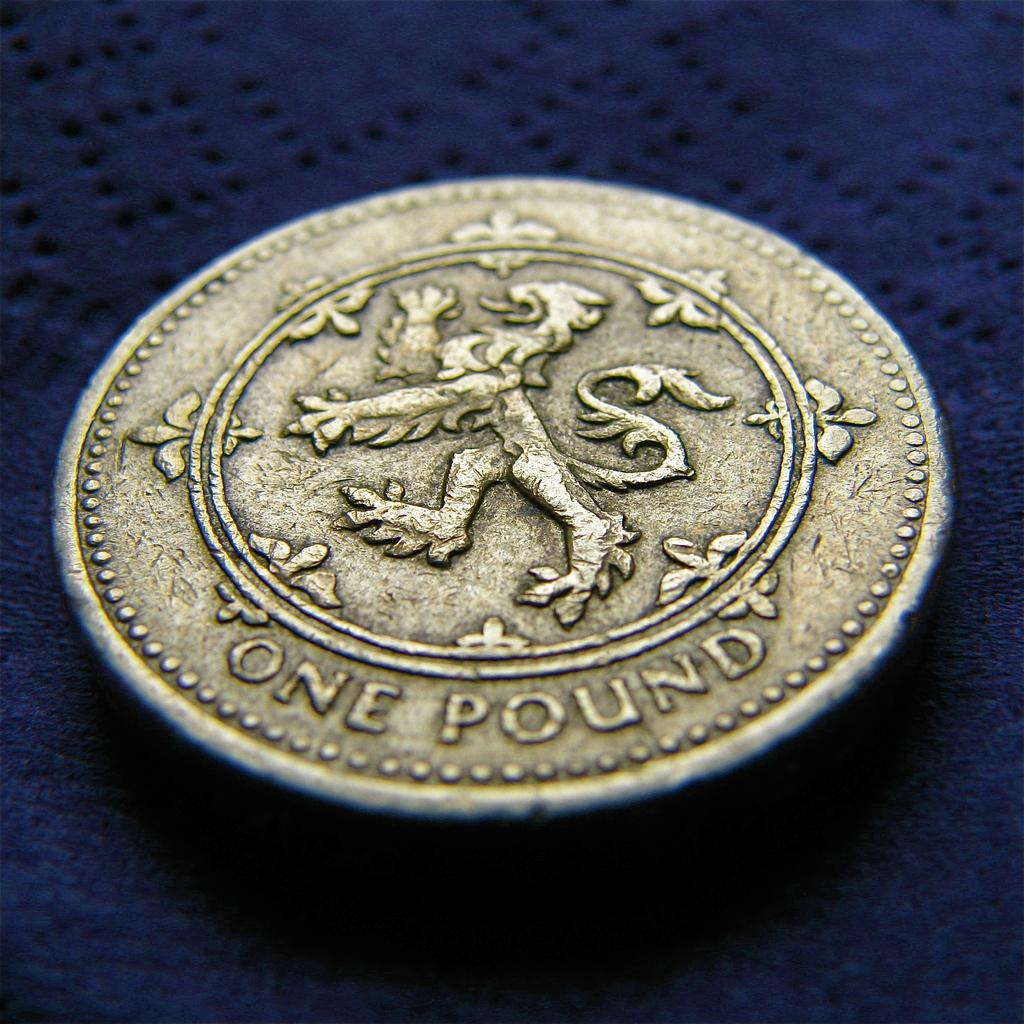<image>
Present a compact description of the photo's key features. A one pound coin is gold in color. 